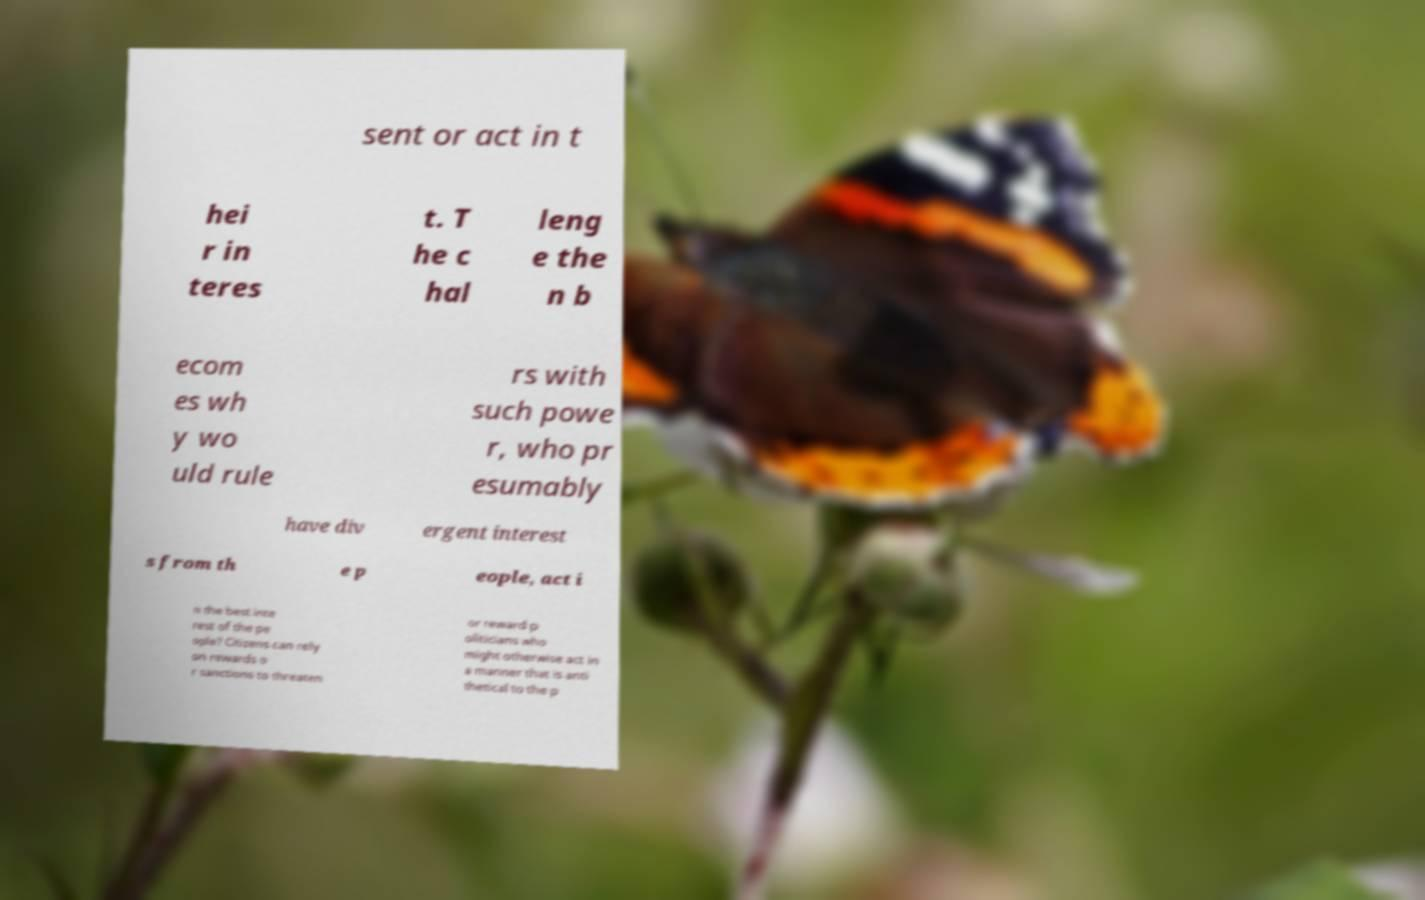Could you extract and type out the text from this image? sent or act in t hei r in teres t. T he c hal leng e the n b ecom es wh y wo uld rule rs with such powe r, who pr esumably have div ergent interest s from th e p eople, act i n the best inte rest of the pe ople? Citizens can rely on rewards o r sanctions to threaten or reward p oliticians who might otherwise act in a manner that is anti thetical to the p 